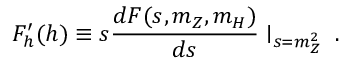Convert formula to latex. <formula><loc_0><loc_0><loc_500><loc_500>F _ { h } ^ { \prime } ( h ) \equiv s \frac { d F ( s , m _ { Z } , m _ { H } ) } { d s } | _ { s = m _ { Z } ^ { 2 } } \, .</formula> 